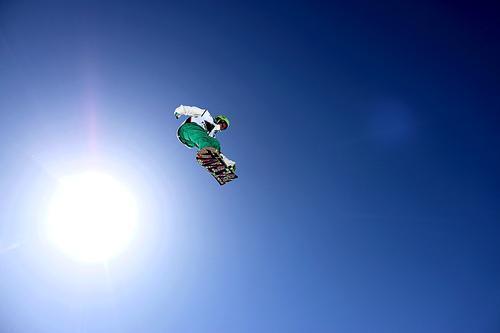How many people are in this?
Give a very brief answer. 1. 